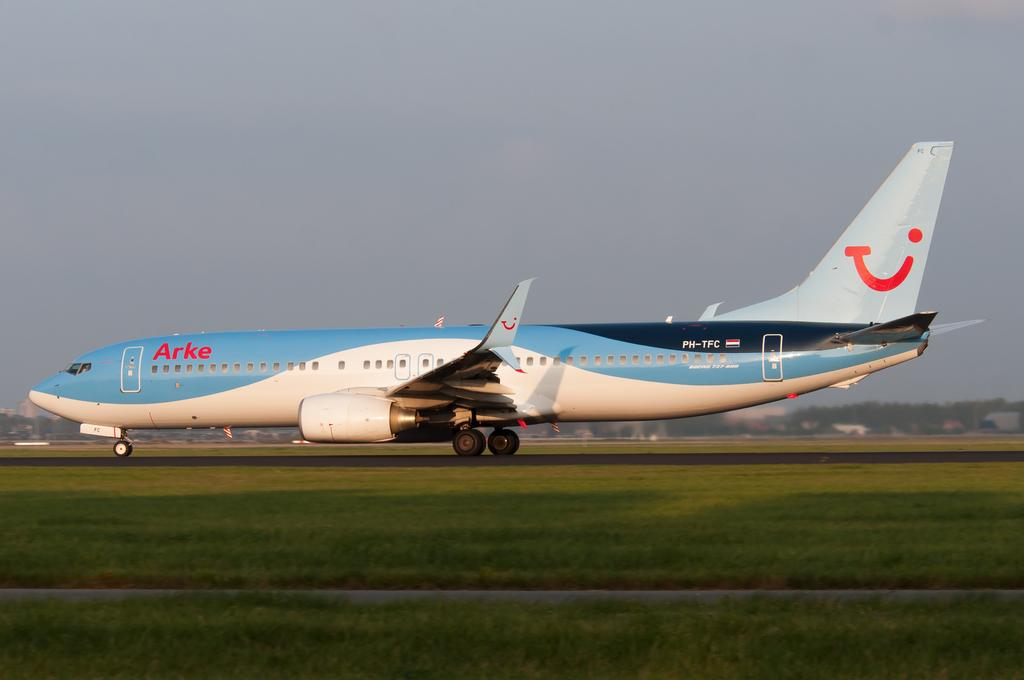<image>
Present a compact description of the photo's key features. An ARKE jet liner on the runway ready for takeoff. 